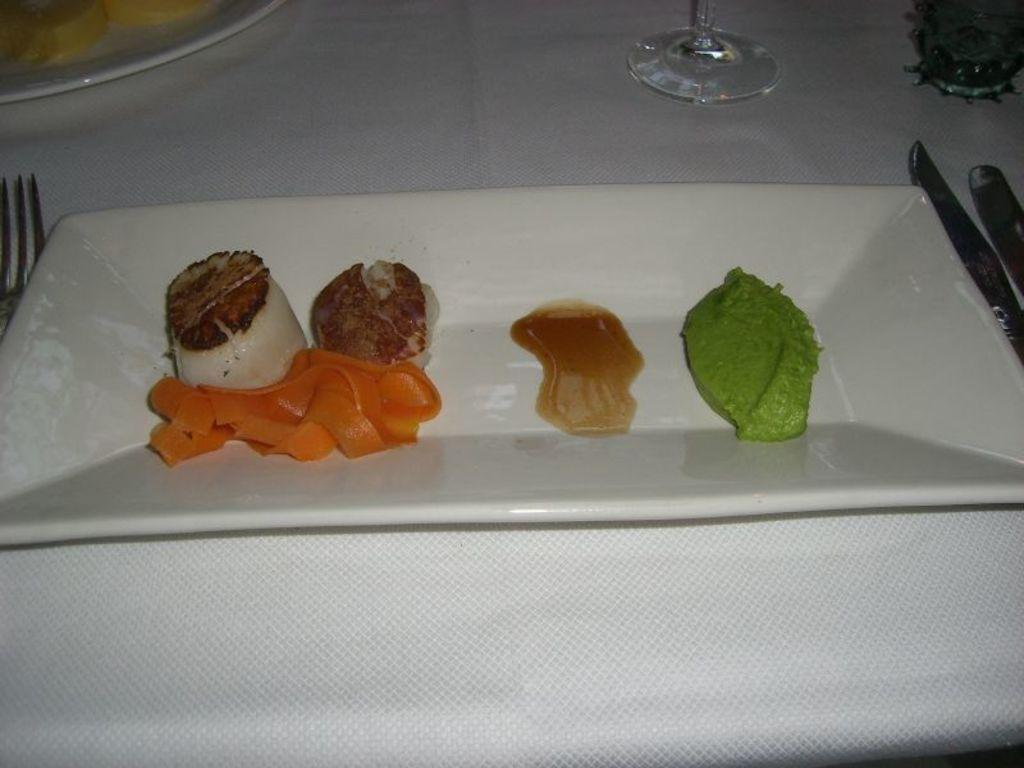What is on the white plate in the image? There are food items on a white plate in the image. What utensils are visible in the image? There is a fork and a knife in the image. Can you describe the other plate in the image? There is another plate in the image, but no details about its contents are provided. What type of container is present for holding a beverage? There is a glass in the image for holding a beverage. What is covering the table in the image? The table has a white tablecloth on it. How many clovers are growing on the tablecloth in the image? There are no clovers present on the tablecloth in the image. What is the degree of cleanliness of the dirt on the floor in the image? There is no dirt present on the floor in the image. 